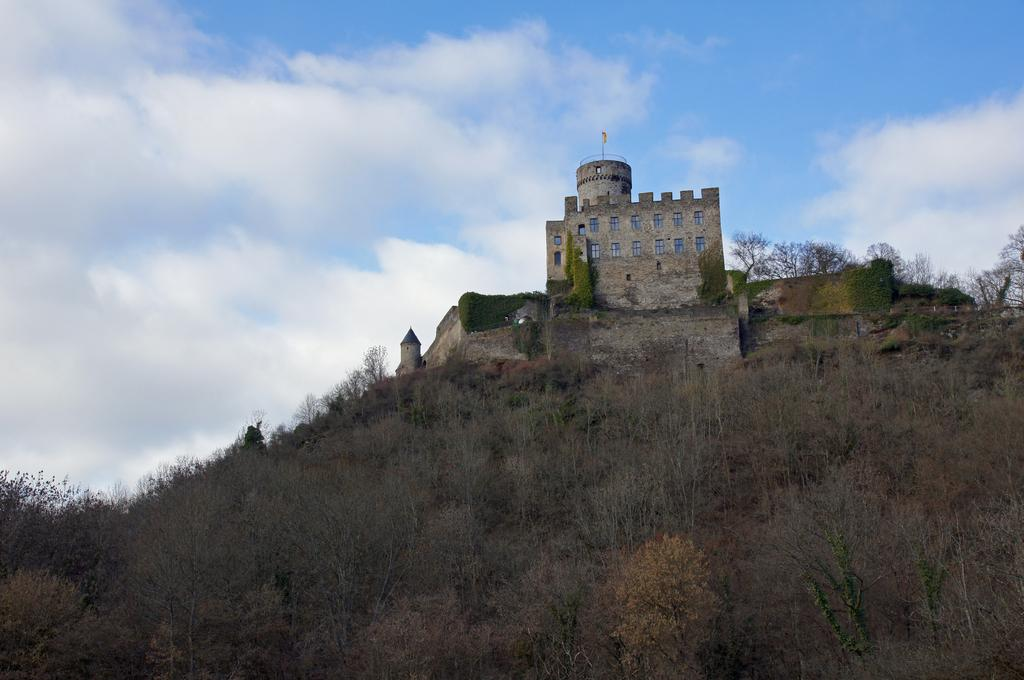What is the main subject in the center of the image? There is a castle in the center of the image. What type of natural elements can be seen in the image? There are trees in the image. What can be seen in the background of the image? The sky is visible in the background of the image. Can you tell me how many crayons are on the castle's roof in the image? There are no crayons present in the image, and therefore no such objects can be found on the castle's roof. 